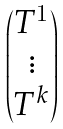<formula> <loc_0><loc_0><loc_500><loc_500>\begin{pmatrix} { T } ^ { 1 } \\ \vdots \\ { T } ^ { k } \end{pmatrix}</formula> 